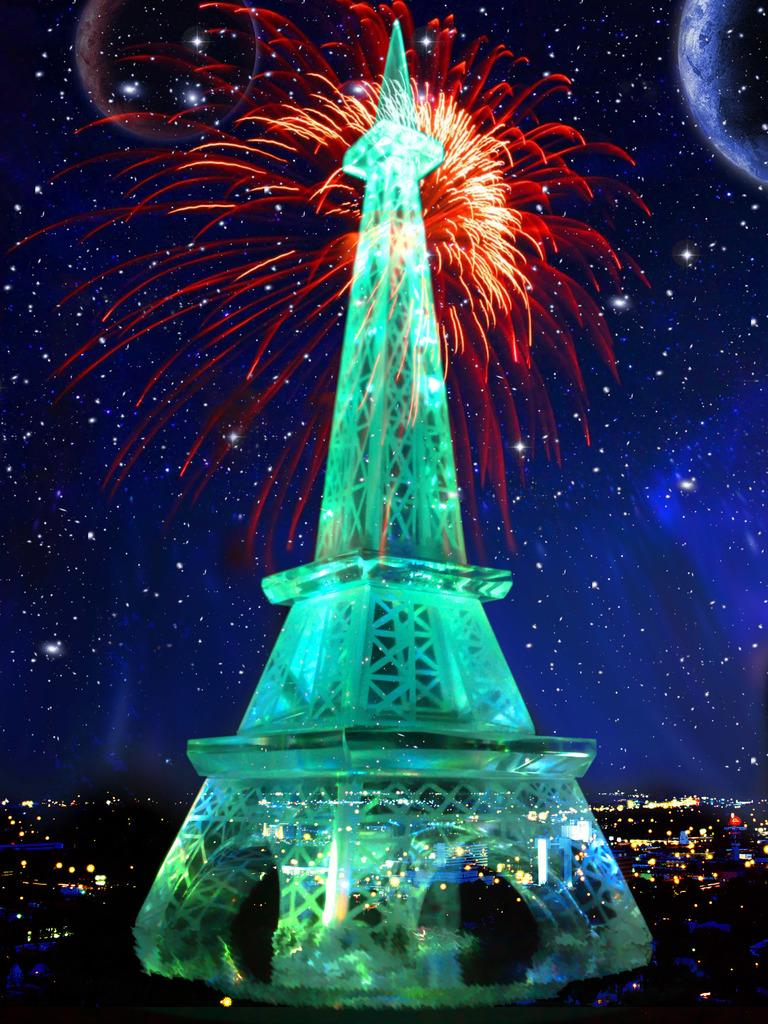What is the main structure in the image? There is a tower in the image. What can be seen in the background of the image? There are lights and the sky visible in the background of the image. Where is the brother standing in the image? There is no brother present in the image. What shape is the kitty in the image? There is no kitty present in the image. 